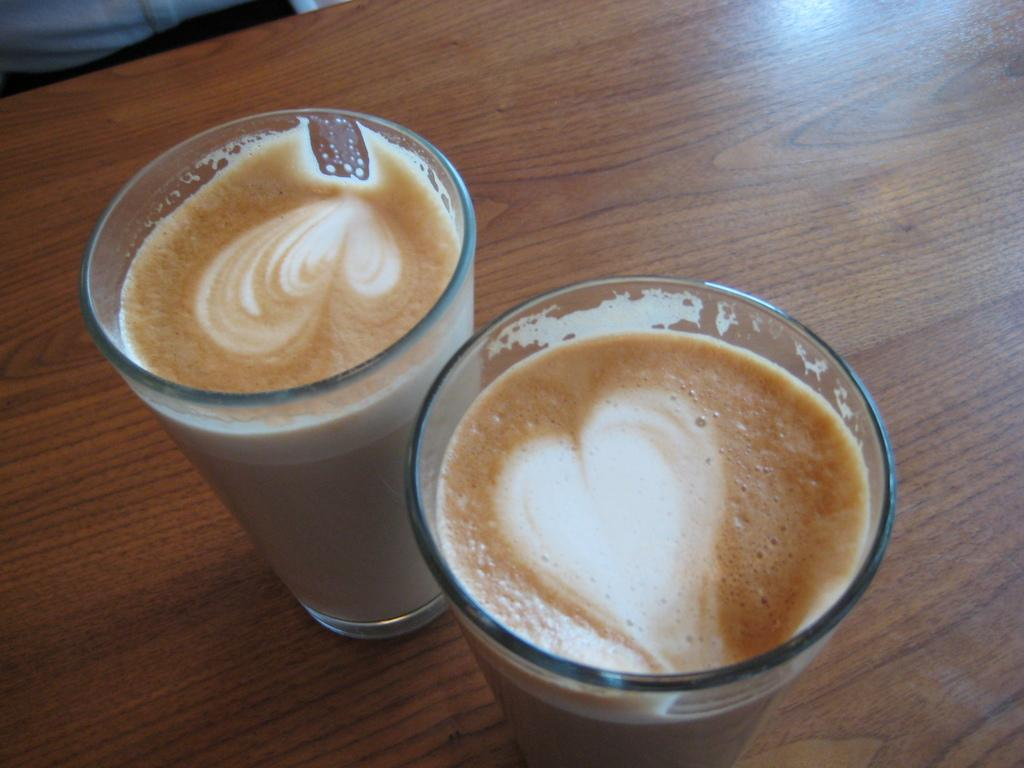How many glasses are visible in the image? There are two glasses in the image. What is inside the glasses? The glasses contain a drink with foam. On what surface are the glasses placed? The glasses are placed on a wooden table. What type of cheese is being used as a representative for the foam in the image? There is no cheese present in the image, and the foam is not a representation of cheese. 